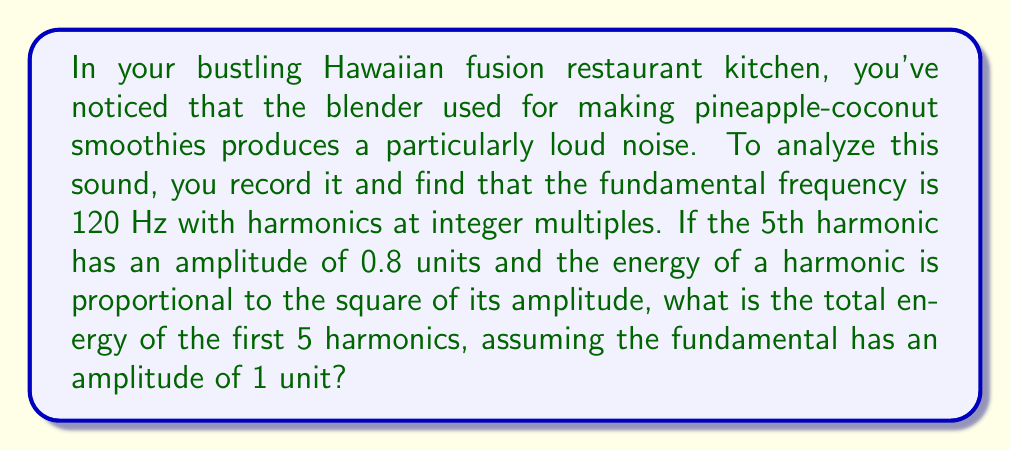Show me your answer to this math problem. Let's approach this step-by-step:

1) First, let's identify the frequencies and amplitudes of the first 5 harmonics:
   - 1st harmonic (fundamental): 120 Hz, amplitude = 1
   - 2nd harmonic: 240 Hz, amplitude unknown
   - 3rd harmonic: 360 Hz, amplitude unknown
   - 4th harmonic: 480 Hz, amplitude unknown
   - 5th harmonic: 600 Hz, amplitude = 0.8

2) We're told that the energy of a harmonic is proportional to the square of its amplitude. Let's call the proportionality constant $k$. So for each harmonic:

   $E_n = k A_n^2$

   where $E_n$ is the energy and $A_n$ is the amplitude of the nth harmonic.

3) We don't need to know the value of $k$ because we're only interested in the relative energies. Let's set $k=1$ for simplicity.

4) Now we can calculate the energy for the known harmonics:
   - 1st harmonic: $E_1 = 1^2 = 1$
   - 5th harmonic: $E_5 = 0.8^2 = 0.64$

5) We don't know the amplitudes of the 2nd, 3rd, and 4th harmonics, but we know their energies must be between 0 and 1 (since the fundamental has the highest amplitude).

6) To maximize the total energy, we should assume these unknown harmonics have the maximum possible energy, which is 1.

7) Therefore, the maximum total energy of the first 5 harmonics is:

   $E_{total} = 1 + 1 + 1 + 1 + 0.64 = 4.64$

This represents the upper bound of the total energy for the first 5 harmonics given the information provided.
Answer: 4.64 units 